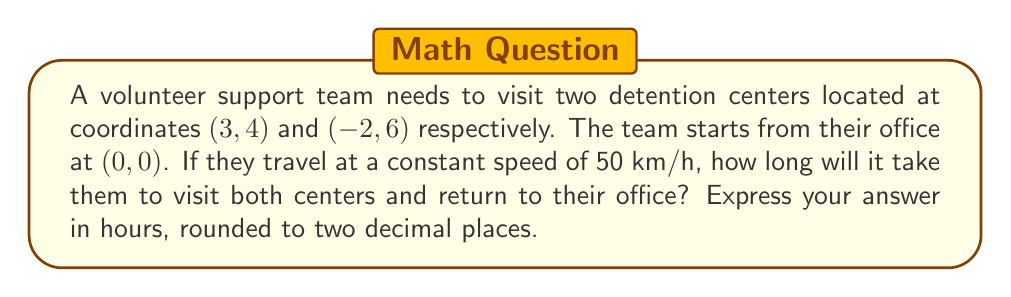Solve this math problem. Let's approach this step-by-step using vector calculations:

1) First, let's calculate the distances between each point:

   Office to Center 1: 
   $$\vec{v_1} = (3-0, 4-0) = (3, 4)$$
   $$|\vec{v_1}| = \sqrt{3^2 + 4^2} = 5 \text{ km}$$

   Center 1 to Center 2:
   $$\vec{v_2} = (-2-3, 6-4) = (-5, 2)$$
   $$|\vec{v_2}| = \sqrt{(-5)^2 + 2^2} = \sqrt{29} \text{ km}$$

   Center 2 back to Office:
   $$\vec{v_3} = (0-(-2), 0-6) = (2, -6)$$
   $$|\vec{v_3}| = \sqrt{2^2 + (-6)^2} = \sqrt{40} = 2\sqrt{10} \text{ km}$$

2) Total distance:
   $$d_{total} = 5 + \sqrt{29} + 2\sqrt{10} \text{ km}$$

3) Time calculation:
   $$t = \frac{d_{total}}{speed} = \frac{5 + \sqrt{29} + 2\sqrt{10}}{50} \text{ hours}$$

4) Evaluating and rounding to two decimal places:
   $$t \approx 0.62 \text{ hours}$$
Answer: 0.62 hours 